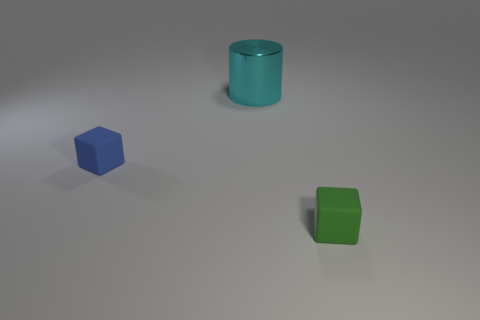Is there anything else that is made of the same material as the large cylinder?
Offer a terse response. No. What material is the object behind the blue thing?
Your answer should be compact. Metal. Is there anything else of the same color as the cylinder?
Your answer should be compact. No. What number of large objects are either blue objects or yellow rubber cylinders?
Provide a succinct answer. 0. There is a cylinder behind the object that is on the right side of the big cyan shiny thing behind the blue thing; what is its size?
Make the answer very short. Large. How many blocks have the same size as the green object?
Offer a terse response. 1. What number of objects are either big metallic cylinders or tiny cubes that are on the left side of the green rubber cube?
Your answer should be very brief. 2. The small blue rubber object has what shape?
Your answer should be very brief. Cube. What is the color of the other object that is the same size as the green matte thing?
Your answer should be very brief. Blue. How many yellow objects are either cylinders or matte objects?
Keep it short and to the point. 0. 